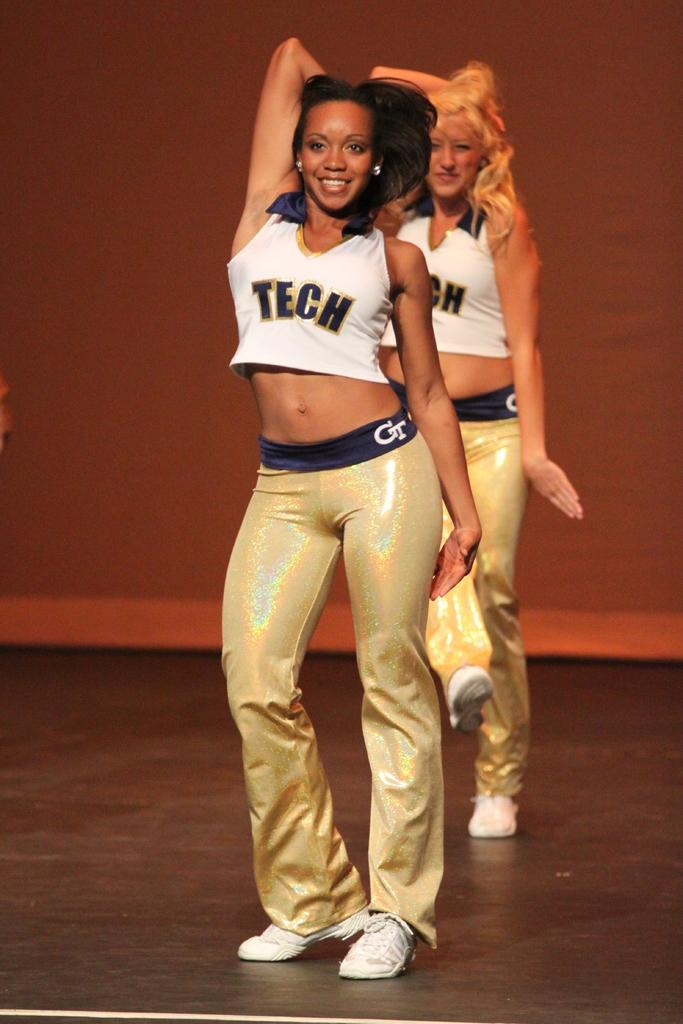How many people are in the image? There are two women in the image. What are the women doing in the image? The women are dancing. What can be seen in the background of the image? There is a curtain in the background of the image. Who is wearing the crown in the image? There is no crown present in the image. What emotion are the women feeling while dancing in the image? The image does not provide information about the emotions of the women. 